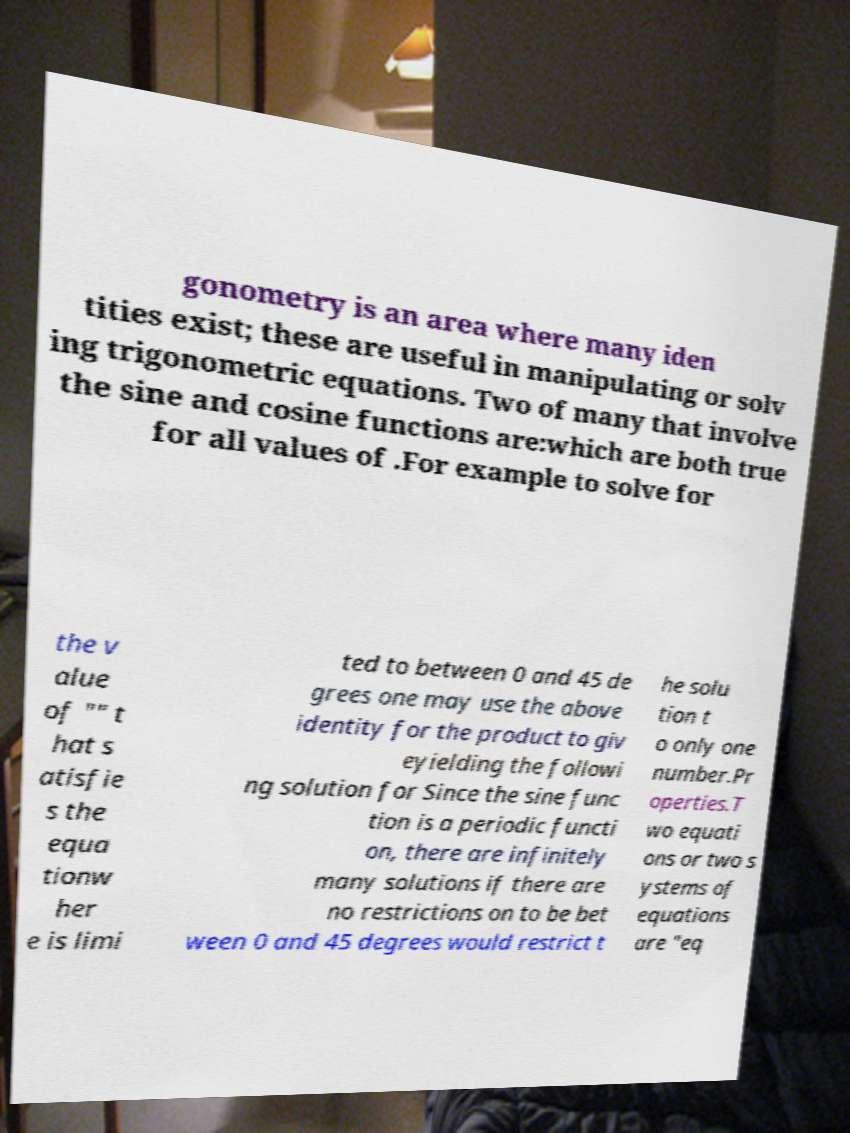For documentation purposes, I need the text within this image transcribed. Could you provide that? gonometry is an area where many iden tities exist; these are useful in manipulating or solv ing trigonometric equations. Two of many that involve the sine and cosine functions are:which are both true for all values of .For example to solve for the v alue of "" t hat s atisfie s the equa tionw her e is limi ted to between 0 and 45 de grees one may use the above identity for the product to giv eyielding the followi ng solution for Since the sine func tion is a periodic functi on, there are infinitely many solutions if there are no restrictions on to be bet ween 0 and 45 degrees would restrict t he solu tion t o only one number.Pr operties.T wo equati ons or two s ystems of equations are "eq 